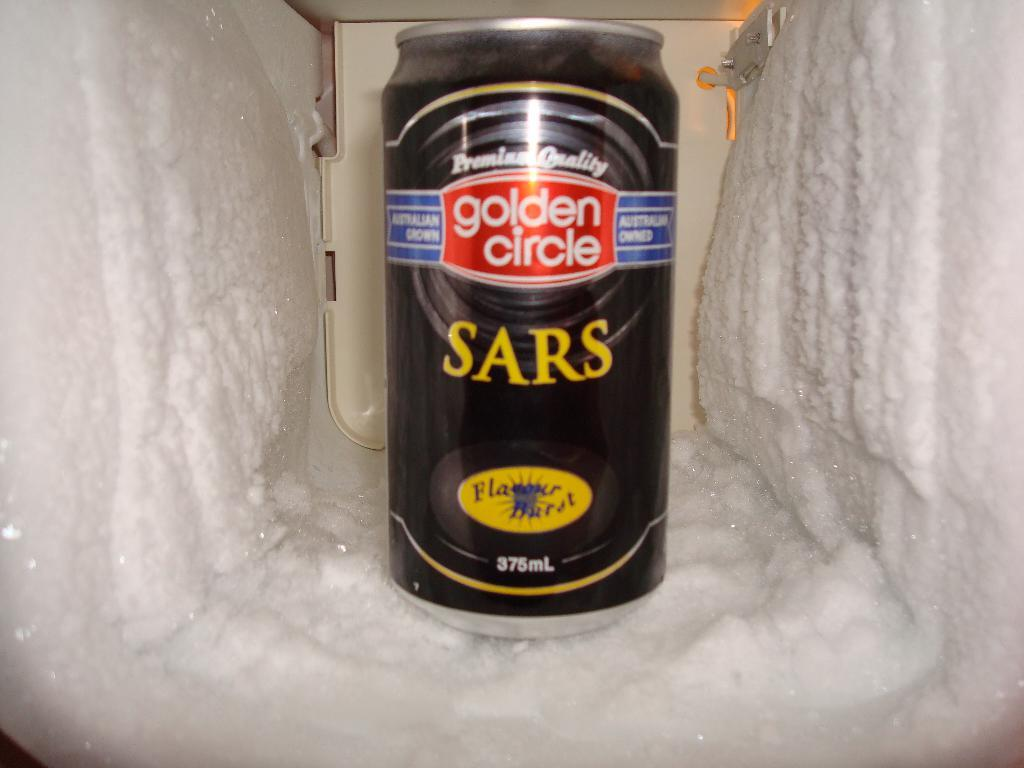<image>
Share a concise interpretation of the image provided. A can of SARS beer says "golden circle" on it. 